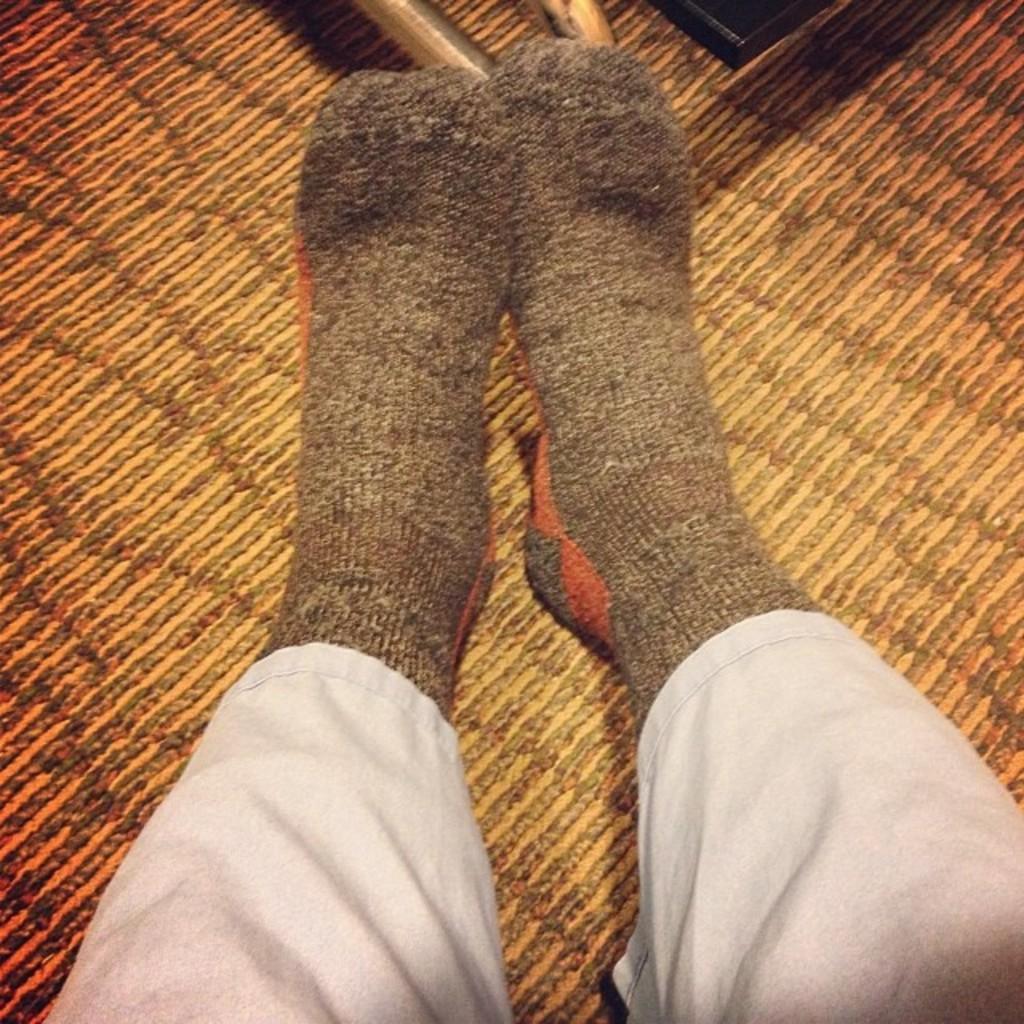How would you summarize this image in a sentence or two? In the image there is a person legs with socks to it on a carpet floor. 